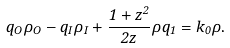<formula> <loc_0><loc_0><loc_500><loc_500>q _ { O } \rho _ { O } - q _ { I } \rho _ { I } + \frac { 1 + z ^ { 2 } } { 2 z } \rho q _ { 1 } = k _ { 0 } \rho .</formula> 